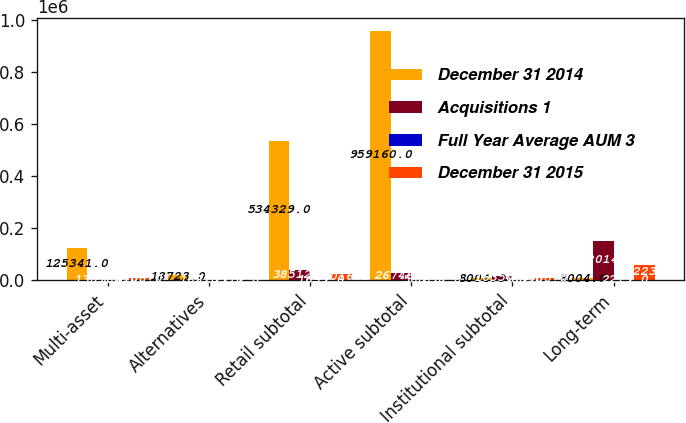Convert chart to OTSL. <chart><loc_0><loc_0><loc_500><loc_500><stacked_bar_chart><ecel><fcel>Multi-asset<fcel>Alternatives<fcel>Retail subtotal<fcel>Active subtotal<fcel>Institutional subtotal<fcel>Long-term<nl><fcel>December 31 2014<fcel>125341<fcel>18723<fcel>534329<fcel>959160<fcel>8004<fcel>8004<nl><fcel>Acquisitions 1<fcel>1307<fcel>162<fcel>38512<fcel>26746<fcel>16350<fcel>152014<nl><fcel>Full Year Average AUM 3<fcel>366<fcel>1293<fcel>1659<fcel>560<fcel>560<fcel>2219<nl><fcel>December 31 2015<fcel>8108<fcel>177<fcel>24016<fcel>639<fcel>7900<fcel>58223<nl></chart> 